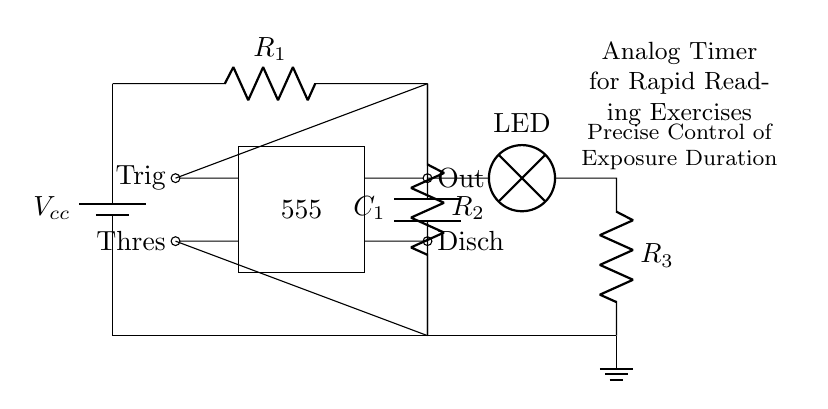What type of circuit is shown here? The diagram represents an analog timer circuit, which is used for precise control of exposure duration in rapid reading exercises. The presence of a timer IC and components configuration indicates its function as a timer.
Answer: analog timer What component is labeled 555? The 555 is an integrated circuit timer, which is commonly used in various timing applications. In this circuit, it performs as the timer that controls the duration of the exposure.
Answer: timer IC How many resistors are in the circuit? The diagram shows two resistors labeled R1 and R2, which are essential for setting the timing intervals in conjunction with the capacitor.
Answer: two What is the role of the capacitor in the circuit? The capacitor (C1) stores charge, and its value, along with the resistors, determines the timing duration for the exposure control. When it discharges, it affects the timing output of the 555 timer.
Answer: timing duration Where is the output located in the circuit? The output is located at the terminal labeled "Out" connected to an LED, which indicates when the timer is active. This shows that the LED will light based on the timer circuit's operation.
Answer: at the Out Which component allows the control of exposure duration? The combination of resistors (R1, R2) and the capacitor (C1) sets the time constant that dictates how long the LED illuminates, hence controlling the exposure duration for reading exercises.
Answer: R1, R2, C1 What is the purpose of the ground connection in the circuit? The ground connection ensures a common return path for the circuit and stabilizes the operation of the timer circuit by providing a reference voltage level. This is crucial for proper functioning of the IC.
Answer: reference voltage level 